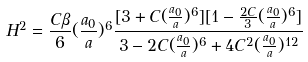Convert formula to latex. <formula><loc_0><loc_0><loc_500><loc_500>H ^ { 2 } = \frac { C \beta } { 6 } ( \frac { a _ { 0 } } { a } ) ^ { 6 } \frac { [ 3 + C ( \frac { a _ { 0 } } { a } ) ^ { 6 } ] [ 1 - \frac { 2 C } { 3 } ( \frac { a _ { 0 } } { a } ) ^ { 6 } ] } { 3 - 2 C ( \frac { a _ { 0 } } { a } ) ^ { 6 } + 4 C ^ { 2 } ( \frac { a _ { 0 } } { a } ) ^ { 1 2 } }</formula> 